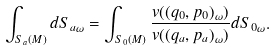Convert formula to latex. <formula><loc_0><loc_0><loc_500><loc_500>\int _ { S _ { a } ( M ) } d S _ { a \omega } = \int _ { S _ { 0 } ( M ) } \frac { v ( ( q _ { 0 } , p _ { 0 } ) _ { \omega } ) } { v ( ( q _ { a } , p _ { a } ) _ { \omega } ) } d S _ { 0 \omega } .</formula> 